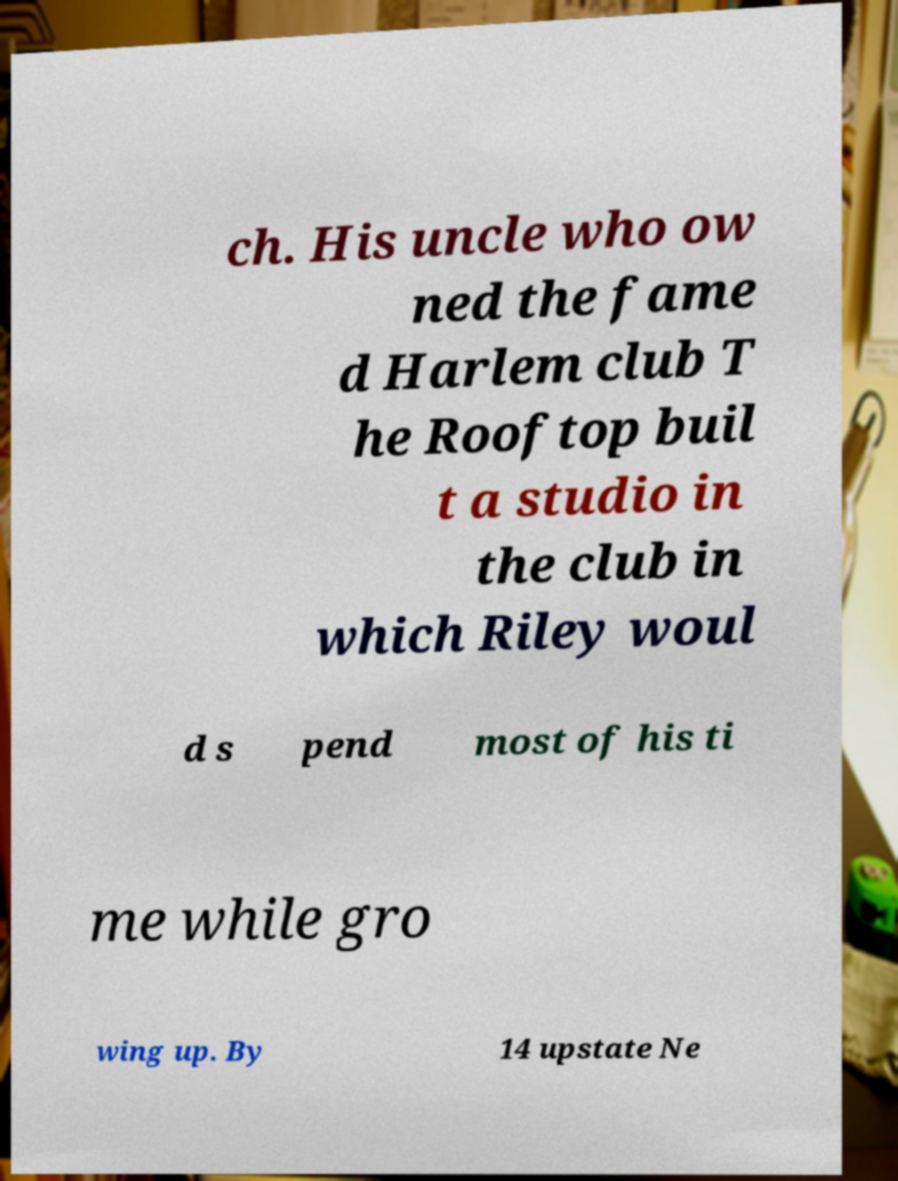Can you accurately transcribe the text from the provided image for me? ch. His uncle who ow ned the fame d Harlem club T he Rooftop buil t a studio in the club in which Riley woul d s pend most of his ti me while gro wing up. By 14 upstate Ne 